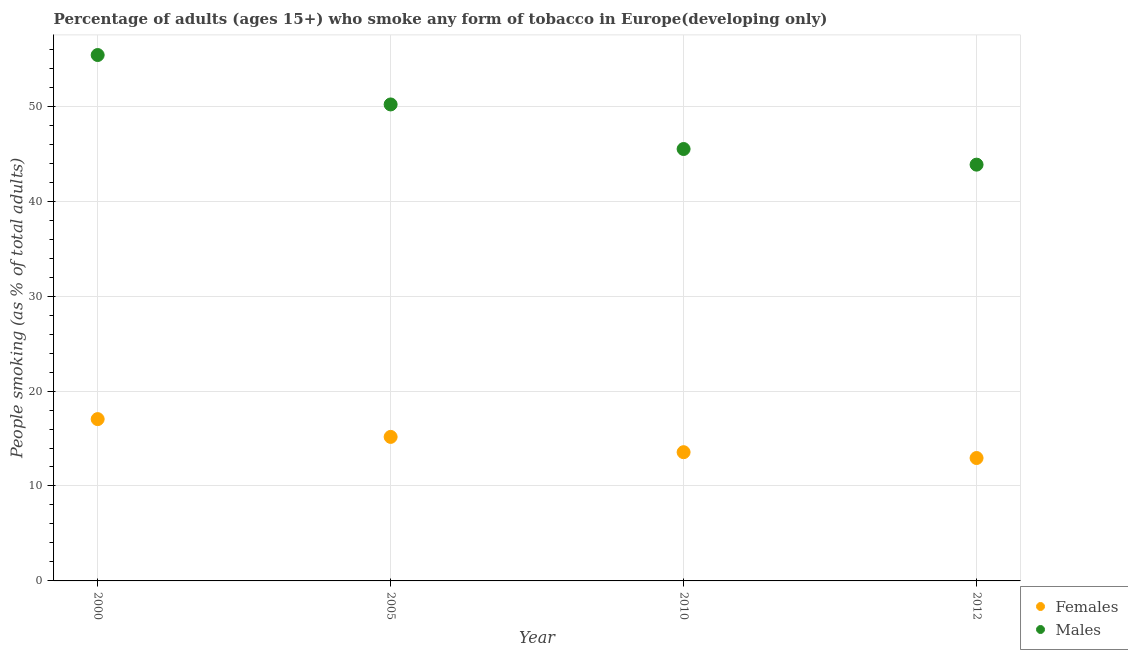How many different coloured dotlines are there?
Your response must be concise. 2. Is the number of dotlines equal to the number of legend labels?
Offer a very short reply. Yes. What is the percentage of females who smoke in 2012?
Offer a very short reply. 12.95. Across all years, what is the maximum percentage of males who smoke?
Your answer should be very brief. 55.4. Across all years, what is the minimum percentage of males who smoke?
Offer a terse response. 43.85. In which year was the percentage of females who smoke maximum?
Your response must be concise. 2000. What is the total percentage of females who smoke in the graph?
Offer a terse response. 58.72. What is the difference between the percentage of females who smoke in 2005 and that in 2012?
Give a very brief answer. 2.22. What is the difference between the percentage of males who smoke in 2010 and the percentage of females who smoke in 2005?
Provide a short and direct response. 30.32. What is the average percentage of males who smoke per year?
Make the answer very short. 48.73. In the year 2005, what is the difference between the percentage of males who smoke and percentage of females who smoke?
Your answer should be compact. 35.02. What is the ratio of the percentage of females who smoke in 2005 to that in 2012?
Offer a very short reply. 1.17. Is the percentage of females who smoke in 2005 less than that in 2010?
Keep it short and to the point. No. What is the difference between the highest and the second highest percentage of males who smoke?
Make the answer very short. 5.21. What is the difference between the highest and the lowest percentage of females who smoke?
Offer a very short reply. 4.1. Is the sum of the percentage of females who smoke in 2000 and 2012 greater than the maximum percentage of males who smoke across all years?
Give a very brief answer. No. Does the percentage of females who smoke monotonically increase over the years?
Give a very brief answer. No. Is the percentage of males who smoke strictly greater than the percentage of females who smoke over the years?
Your response must be concise. Yes. Is the percentage of females who smoke strictly less than the percentage of males who smoke over the years?
Your response must be concise. Yes. What is the difference between two consecutive major ticks on the Y-axis?
Provide a short and direct response. 10. Are the values on the major ticks of Y-axis written in scientific E-notation?
Your response must be concise. No. Does the graph contain any zero values?
Offer a terse response. No. How many legend labels are there?
Ensure brevity in your answer.  2. What is the title of the graph?
Your answer should be very brief. Percentage of adults (ages 15+) who smoke any form of tobacco in Europe(developing only). Does "Urban" appear as one of the legend labels in the graph?
Offer a very short reply. No. What is the label or title of the Y-axis?
Offer a terse response. People smoking (as % of total adults). What is the People smoking (as % of total adults) in Females in 2000?
Ensure brevity in your answer.  17.04. What is the People smoking (as % of total adults) in Males in 2000?
Your answer should be compact. 55.4. What is the People smoking (as % of total adults) in Females in 2005?
Offer a very short reply. 15.17. What is the People smoking (as % of total adults) in Males in 2005?
Ensure brevity in your answer.  50.19. What is the People smoking (as % of total adults) of Females in 2010?
Ensure brevity in your answer.  13.56. What is the People smoking (as % of total adults) in Males in 2010?
Keep it short and to the point. 45.5. What is the People smoking (as % of total adults) of Females in 2012?
Keep it short and to the point. 12.95. What is the People smoking (as % of total adults) of Males in 2012?
Offer a very short reply. 43.85. Across all years, what is the maximum People smoking (as % of total adults) in Females?
Your response must be concise. 17.04. Across all years, what is the maximum People smoking (as % of total adults) in Males?
Provide a succinct answer. 55.4. Across all years, what is the minimum People smoking (as % of total adults) in Females?
Provide a succinct answer. 12.95. Across all years, what is the minimum People smoking (as % of total adults) in Males?
Your answer should be compact. 43.85. What is the total People smoking (as % of total adults) in Females in the graph?
Provide a short and direct response. 58.72. What is the total People smoking (as % of total adults) of Males in the graph?
Offer a very short reply. 194.93. What is the difference between the People smoking (as % of total adults) of Females in 2000 and that in 2005?
Offer a terse response. 1.87. What is the difference between the People smoking (as % of total adults) of Males in 2000 and that in 2005?
Your answer should be compact. 5.21. What is the difference between the People smoking (as % of total adults) in Females in 2000 and that in 2010?
Give a very brief answer. 3.48. What is the difference between the People smoking (as % of total adults) in Males in 2000 and that in 2010?
Your response must be concise. 9.9. What is the difference between the People smoking (as % of total adults) of Females in 2000 and that in 2012?
Provide a short and direct response. 4.1. What is the difference between the People smoking (as % of total adults) in Males in 2000 and that in 2012?
Give a very brief answer. 11.55. What is the difference between the People smoking (as % of total adults) of Females in 2005 and that in 2010?
Your answer should be very brief. 1.61. What is the difference between the People smoking (as % of total adults) in Males in 2005 and that in 2010?
Provide a succinct answer. 4.69. What is the difference between the People smoking (as % of total adults) in Females in 2005 and that in 2012?
Give a very brief answer. 2.22. What is the difference between the People smoking (as % of total adults) in Males in 2005 and that in 2012?
Your answer should be compact. 6.34. What is the difference between the People smoking (as % of total adults) in Females in 2010 and that in 2012?
Offer a terse response. 0.61. What is the difference between the People smoking (as % of total adults) of Males in 2010 and that in 2012?
Offer a very short reply. 1.65. What is the difference between the People smoking (as % of total adults) of Females in 2000 and the People smoking (as % of total adults) of Males in 2005?
Make the answer very short. -33.15. What is the difference between the People smoking (as % of total adults) in Females in 2000 and the People smoking (as % of total adults) in Males in 2010?
Make the answer very short. -28.45. What is the difference between the People smoking (as % of total adults) of Females in 2000 and the People smoking (as % of total adults) of Males in 2012?
Make the answer very short. -26.8. What is the difference between the People smoking (as % of total adults) of Females in 2005 and the People smoking (as % of total adults) of Males in 2010?
Make the answer very short. -30.32. What is the difference between the People smoking (as % of total adults) of Females in 2005 and the People smoking (as % of total adults) of Males in 2012?
Give a very brief answer. -28.68. What is the difference between the People smoking (as % of total adults) of Females in 2010 and the People smoking (as % of total adults) of Males in 2012?
Keep it short and to the point. -30.29. What is the average People smoking (as % of total adults) in Females per year?
Give a very brief answer. 14.68. What is the average People smoking (as % of total adults) of Males per year?
Ensure brevity in your answer.  48.73. In the year 2000, what is the difference between the People smoking (as % of total adults) in Females and People smoking (as % of total adults) in Males?
Offer a very short reply. -38.35. In the year 2005, what is the difference between the People smoking (as % of total adults) in Females and People smoking (as % of total adults) in Males?
Provide a succinct answer. -35.02. In the year 2010, what is the difference between the People smoking (as % of total adults) in Females and People smoking (as % of total adults) in Males?
Ensure brevity in your answer.  -31.94. In the year 2012, what is the difference between the People smoking (as % of total adults) of Females and People smoking (as % of total adults) of Males?
Keep it short and to the point. -30.9. What is the ratio of the People smoking (as % of total adults) of Females in 2000 to that in 2005?
Keep it short and to the point. 1.12. What is the ratio of the People smoking (as % of total adults) in Males in 2000 to that in 2005?
Offer a terse response. 1.1. What is the ratio of the People smoking (as % of total adults) of Females in 2000 to that in 2010?
Your answer should be very brief. 1.26. What is the ratio of the People smoking (as % of total adults) of Males in 2000 to that in 2010?
Provide a short and direct response. 1.22. What is the ratio of the People smoking (as % of total adults) of Females in 2000 to that in 2012?
Your response must be concise. 1.32. What is the ratio of the People smoking (as % of total adults) of Males in 2000 to that in 2012?
Provide a succinct answer. 1.26. What is the ratio of the People smoking (as % of total adults) in Females in 2005 to that in 2010?
Ensure brevity in your answer.  1.12. What is the ratio of the People smoking (as % of total adults) of Males in 2005 to that in 2010?
Ensure brevity in your answer.  1.1. What is the ratio of the People smoking (as % of total adults) in Females in 2005 to that in 2012?
Provide a succinct answer. 1.17. What is the ratio of the People smoking (as % of total adults) in Males in 2005 to that in 2012?
Keep it short and to the point. 1.14. What is the ratio of the People smoking (as % of total adults) of Females in 2010 to that in 2012?
Make the answer very short. 1.05. What is the ratio of the People smoking (as % of total adults) of Males in 2010 to that in 2012?
Offer a very short reply. 1.04. What is the difference between the highest and the second highest People smoking (as % of total adults) in Females?
Provide a short and direct response. 1.87. What is the difference between the highest and the second highest People smoking (as % of total adults) of Males?
Your answer should be compact. 5.21. What is the difference between the highest and the lowest People smoking (as % of total adults) in Females?
Offer a very short reply. 4.1. What is the difference between the highest and the lowest People smoking (as % of total adults) of Males?
Keep it short and to the point. 11.55. 